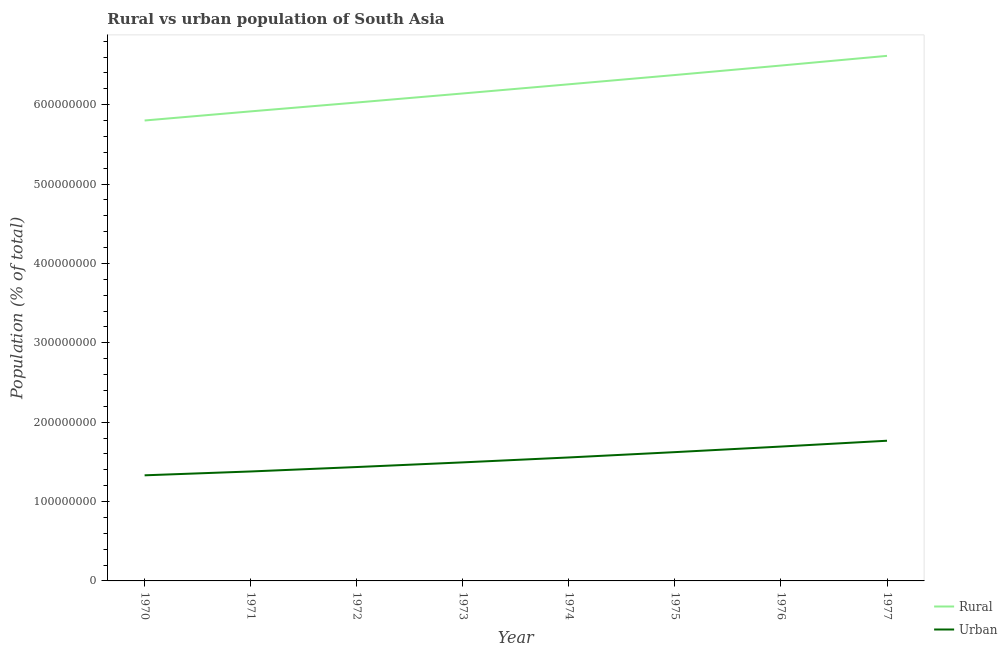Does the line corresponding to rural population density intersect with the line corresponding to urban population density?
Offer a terse response. No. Is the number of lines equal to the number of legend labels?
Provide a succinct answer. Yes. What is the rural population density in 1970?
Ensure brevity in your answer.  5.80e+08. Across all years, what is the maximum urban population density?
Make the answer very short. 1.77e+08. Across all years, what is the minimum urban population density?
Provide a succinct answer. 1.33e+08. In which year was the rural population density minimum?
Make the answer very short. 1970. What is the total urban population density in the graph?
Your answer should be compact. 1.23e+09. What is the difference between the urban population density in 1972 and that in 1974?
Provide a succinct answer. -1.21e+07. What is the difference between the urban population density in 1971 and the rural population density in 1972?
Your answer should be very brief. -4.65e+08. What is the average rural population density per year?
Offer a terse response. 6.20e+08. In the year 1975, what is the difference between the rural population density and urban population density?
Offer a very short reply. 4.75e+08. In how many years, is the rural population density greater than 40000000 %?
Your answer should be compact. 8. What is the ratio of the urban population density in 1972 to that in 1974?
Your answer should be very brief. 0.92. Is the difference between the rural population density in 1971 and 1972 greater than the difference between the urban population density in 1971 and 1972?
Provide a succinct answer. No. What is the difference between the highest and the second highest urban population density?
Give a very brief answer. 7.35e+06. What is the difference between the highest and the lowest urban population density?
Provide a succinct answer. 4.36e+07. In how many years, is the rural population density greater than the average rural population density taken over all years?
Offer a terse response. 4. Is the sum of the urban population density in 1972 and 1973 greater than the maximum rural population density across all years?
Provide a succinct answer. No. Is the urban population density strictly greater than the rural population density over the years?
Ensure brevity in your answer.  No. How many lines are there?
Your answer should be compact. 2. What is the difference between two consecutive major ticks on the Y-axis?
Your response must be concise. 1.00e+08. Does the graph contain any zero values?
Your answer should be very brief. No. Does the graph contain grids?
Provide a short and direct response. No. Where does the legend appear in the graph?
Make the answer very short. Bottom right. What is the title of the graph?
Offer a terse response. Rural vs urban population of South Asia. Does "Start a business" appear as one of the legend labels in the graph?
Your answer should be very brief. No. What is the label or title of the Y-axis?
Give a very brief answer. Population (% of total). What is the Population (% of total) in Rural in 1970?
Ensure brevity in your answer.  5.80e+08. What is the Population (% of total) in Urban in 1970?
Ensure brevity in your answer.  1.33e+08. What is the Population (% of total) of Rural in 1971?
Provide a short and direct response. 5.92e+08. What is the Population (% of total) in Urban in 1971?
Give a very brief answer. 1.38e+08. What is the Population (% of total) of Rural in 1972?
Make the answer very short. 6.03e+08. What is the Population (% of total) in Urban in 1972?
Keep it short and to the point. 1.43e+08. What is the Population (% of total) in Rural in 1973?
Ensure brevity in your answer.  6.14e+08. What is the Population (% of total) of Urban in 1973?
Your answer should be compact. 1.49e+08. What is the Population (% of total) in Rural in 1974?
Provide a succinct answer. 6.26e+08. What is the Population (% of total) of Urban in 1974?
Keep it short and to the point. 1.56e+08. What is the Population (% of total) of Rural in 1975?
Your answer should be very brief. 6.37e+08. What is the Population (% of total) in Urban in 1975?
Provide a succinct answer. 1.62e+08. What is the Population (% of total) of Rural in 1976?
Your answer should be compact. 6.49e+08. What is the Population (% of total) of Urban in 1976?
Your answer should be very brief. 1.69e+08. What is the Population (% of total) in Rural in 1977?
Your answer should be compact. 6.62e+08. What is the Population (% of total) of Urban in 1977?
Make the answer very short. 1.77e+08. Across all years, what is the maximum Population (% of total) of Rural?
Ensure brevity in your answer.  6.62e+08. Across all years, what is the maximum Population (% of total) in Urban?
Offer a very short reply. 1.77e+08. Across all years, what is the minimum Population (% of total) of Rural?
Keep it short and to the point. 5.80e+08. Across all years, what is the minimum Population (% of total) in Urban?
Offer a terse response. 1.33e+08. What is the total Population (% of total) of Rural in the graph?
Offer a terse response. 4.96e+09. What is the total Population (% of total) in Urban in the graph?
Make the answer very short. 1.23e+09. What is the difference between the Population (% of total) in Rural in 1970 and that in 1971?
Make the answer very short. -1.15e+07. What is the difference between the Population (% of total) of Urban in 1970 and that in 1971?
Give a very brief answer. -4.86e+06. What is the difference between the Population (% of total) of Rural in 1970 and that in 1972?
Your answer should be compact. -2.27e+07. What is the difference between the Population (% of total) in Urban in 1970 and that in 1972?
Keep it short and to the point. -1.05e+07. What is the difference between the Population (% of total) in Rural in 1970 and that in 1973?
Your answer should be compact. -3.41e+07. What is the difference between the Population (% of total) of Urban in 1970 and that in 1973?
Offer a terse response. -1.63e+07. What is the difference between the Population (% of total) of Rural in 1970 and that in 1974?
Your answer should be compact. -4.56e+07. What is the difference between the Population (% of total) of Urban in 1970 and that in 1974?
Your answer should be compact. -2.25e+07. What is the difference between the Population (% of total) in Rural in 1970 and that in 1975?
Make the answer very short. -5.73e+07. What is the difference between the Population (% of total) in Urban in 1970 and that in 1975?
Provide a succinct answer. -2.92e+07. What is the difference between the Population (% of total) of Rural in 1970 and that in 1976?
Your answer should be very brief. -6.93e+07. What is the difference between the Population (% of total) in Urban in 1970 and that in 1976?
Give a very brief answer. -3.62e+07. What is the difference between the Population (% of total) in Rural in 1970 and that in 1977?
Your answer should be very brief. -8.15e+07. What is the difference between the Population (% of total) of Urban in 1970 and that in 1977?
Give a very brief answer. -4.36e+07. What is the difference between the Population (% of total) in Rural in 1971 and that in 1972?
Your answer should be compact. -1.12e+07. What is the difference between the Population (% of total) in Urban in 1971 and that in 1972?
Your answer should be very brief. -5.59e+06. What is the difference between the Population (% of total) of Rural in 1971 and that in 1973?
Provide a succinct answer. -2.26e+07. What is the difference between the Population (% of total) of Urban in 1971 and that in 1973?
Your answer should be compact. -1.14e+07. What is the difference between the Population (% of total) in Rural in 1971 and that in 1974?
Offer a terse response. -3.41e+07. What is the difference between the Population (% of total) of Urban in 1971 and that in 1974?
Ensure brevity in your answer.  -1.77e+07. What is the difference between the Population (% of total) in Rural in 1971 and that in 1975?
Your answer should be compact. -4.58e+07. What is the difference between the Population (% of total) of Urban in 1971 and that in 1975?
Your answer should be very brief. -2.44e+07. What is the difference between the Population (% of total) of Rural in 1971 and that in 1976?
Your response must be concise. -5.78e+07. What is the difference between the Population (% of total) in Urban in 1971 and that in 1976?
Offer a very short reply. -3.14e+07. What is the difference between the Population (% of total) in Rural in 1971 and that in 1977?
Make the answer very short. -7.00e+07. What is the difference between the Population (% of total) in Urban in 1971 and that in 1977?
Ensure brevity in your answer.  -3.87e+07. What is the difference between the Population (% of total) of Rural in 1972 and that in 1973?
Ensure brevity in your answer.  -1.14e+07. What is the difference between the Population (% of total) in Urban in 1972 and that in 1973?
Offer a very short reply. -5.85e+06. What is the difference between the Population (% of total) of Rural in 1972 and that in 1974?
Your answer should be compact. -2.30e+07. What is the difference between the Population (% of total) in Urban in 1972 and that in 1974?
Give a very brief answer. -1.21e+07. What is the difference between the Population (% of total) of Rural in 1972 and that in 1975?
Your answer should be very brief. -3.46e+07. What is the difference between the Population (% of total) in Urban in 1972 and that in 1975?
Keep it short and to the point. -1.88e+07. What is the difference between the Population (% of total) of Rural in 1972 and that in 1976?
Your response must be concise. -4.66e+07. What is the difference between the Population (% of total) of Urban in 1972 and that in 1976?
Ensure brevity in your answer.  -2.58e+07. What is the difference between the Population (% of total) in Rural in 1972 and that in 1977?
Your answer should be very brief. -5.88e+07. What is the difference between the Population (% of total) of Urban in 1972 and that in 1977?
Give a very brief answer. -3.31e+07. What is the difference between the Population (% of total) of Rural in 1973 and that in 1974?
Your answer should be very brief. -1.15e+07. What is the difference between the Population (% of total) of Urban in 1973 and that in 1974?
Your response must be concise. -6.21e+06. What is the difference between the Population (% of total) in Rural in 1973 and that in 1975?
Offer a terse response. -2.32e+07. What is the difference between the Population (% of total) of Urban in 1973 and that in 1975?
Offer a terse response. -1.29e+07. What is the difference between the Population (% of total) in Rural in 1973 and that in 1976?
Your answer should be compact. -3.52e+07. What is the difference between the Population (% of total) in Urban in 1973 and that in 1976?
Your answer should be very brief. -1.99e+07. What is the difference between the Population (% of total) of Rural in 1973 and that in 1977?
Your answer should be compact. -4.74e+07. What is the difference between the Population (% of total) in Urban in 1973 and that in 1977?
Ensure brevity in your answer.  -2.73e+07. What is the difference between the Population (% of total) of Rural in 1974 and that in 1975?
Your response must be concise. -1.17e+07. What is the difference between the Population (% of total) in Urban in 1974 and that in 1975?
Your answer should be compact. -6.69e+06. What is the difference between the Population (% of total) of Rural in 1974 and that in 1976?
Offer a terse response. -2.36e+07. What is the difference between the Population (% of total) of Urban in 1974 and that in 1976?
Provide a succinct answer. -1.37e+07. What is the difference between the Population (% of total) in Rural in 1974 and that in 1977?
Your answer should be very brief. -3.58e+07. What is the difference between the Population (% of total) in Urban in 1974 and that in 1977?
Offer a terse response. -2.11e+07. What is the difference between the Population (% of total) of Rural in 1975 and that in 1976?
Your response must be concise. -1.20e+07. What is the difference between the Population (% of total) of Urban in 1975 and that in 1976?
Ensure brevity in your answer.  -7.01e+06. What is the difference between the Population (% of total) of Rural in 1975 and that in 1977?
Your answer should be very brief. -2.42e+07. What is the difference between the Population (% of total) of Urban in 1975 and that in 1977?
Keep it short and to the point. -1.44e+07. What is the difference between the Population (% of total) in Rural in 1976 and that in 1977?
Keep it short and to the point. -1.22e+07. What is the difference between the Population (% of total) of Urban in 1976 and that in 1977?
Offer a terse response. -7.35e+06. What is the difference between the Population (% of total) of Rural in 1970 and the Population (% of total) of Urban in 1971?
Provide a succinct answer. 4.42e+08. What is the difference between the Population (% of total) of Rural in 1970 and the Population (% of total) of Urban in 1972?
Give a very brief answer. 4.37e+08. What is the difference between the Population (% of total) of Rural in 1970 and the Population (% of total) of Urban in 1973?
Provide a succinct answer. 4.31e+08. What is the difference between the Population (% of total) of Rural in 1970 and the Population (% of total) of Urban in 1974?
Give a very brief answer. 4.25e+08. What is the difference between the Population (% of total) of Rural in 1970 and the Population (% of total) of Urban in 1975?
Keep it short and to the point. 4.18e+08. What is the difference between the Population (% of total) of Rural in 1970 and the Population (% of total) of Urban in 1976?
Your answer should be very brief. 4.11e+08. What is the difference between the Population (% of total) in Rural in 1970 and the Population (% of total) in Urban in 1977?
Keep it short and to the point. 4.03e+08. What is the difference between the Population (% of total) of Rural in 1971 and the Population (% of total) of Urban in 1972?
Your answer should be compact. 4.48e+08. What is the difference between the Population (% of total) of Rural in 1971 and the Population (% of total) of Urban in 1973?
Make the answer very short. 4.42e+08. What is the difference between the Population (% of total) of Rural in 1971 and the Population (% of total) of Urban in 1974?
Make the answer very short. 4.36e+08. What is the difference between the Population (% of total) in Rural in 1971 and the Population (% of total) in Urban in 1975?
Provide a succinct answer. 4.29e+08. What is the difference between the Population (% of total) in Rural in 1971 and the Population (% of total) in Urban in 1976?
Offer a very short reply. 4.22e+08. What is the difference between the Population (% of total) in Rural in 1971 and the Population (% of total) in Urban in 1977?
Ensure brevity in your answer.  4.15e+08. What is the difference between the Population (% of total) in Rural in 1972 and the Population (% of total) in Urban in 1973?
Provide a short and direct response. 4.53e+08. What is the difference between the Population (% of total) in Rural in 1972 and the Population (% of total) in Urban in 1974?
Keep it short and to the point. 4.47e+08. What is the difference between the Population (% of total) in Rural in 1972 and the Population (% of total) in Urban in 1975?
Your answer should be very brief. 4.40e+08. What is the difference between the Population (% of total) of Rural in 1972 and the Population (% of total) of Urban in 1976?
Offer a very short reply. 4.33e+08. What is the difference between the Population (% of total) in Rural in 1972 and the Population (% of total) in Urban in 1977?
Offer a terse response. 4.26e+08. What is the difference between the Population (% of total) in Rural in 1973 and the Population (% of total) in Urban in 1974?
Your answer should be compact. 4.59e+08. What is the difference between the Population (% of total) in Rural in 1973 and the Population (% of total) in Urban in 1975?
Your response must be concise. 4.52e+08. What is the difference between the Population (% of total) of Rural in 1973 and the Population (% of total) of Urban in 1976?
Keep it short and to the point. 4.45e+08. What is the difference between the Population (% of total) of Rural in 1973 and the Population (% of total) of Urban in 1977?
Keep it short and to the point. 4.38e+08. What is the difference between the Population (% of total) of Rural in 1974 and the Population (% of total) of Urban in 1975?
Make the answer very short. 4.63e+08. What is the difference between the Population (% of total) in Rural in 1974 and the Population (% of total) in Urban in 1976?
Provide a succinct answer. 4.56e+08. What is the difference between the Population (% of total) in Rural in 1974 and the Population (% of total) in Urban in 1977?
Your answer should be compact. 4.49e+08. What is the difference between the Population (% of total) of Rural in 1975 and the Population (% of total) of Urban in 1976?
Your answer should be compact. 4.68e+08. What is the difference between the Population (% of total) in Rural in 1975 and the Population (% of total) in Urban in 1977?
Keep it short and to the point. 4.61e+08. What is the difference between the Population (% of total) of Rural in 1976 and the Population (% of total) of Urban in 1977?
Your answer should be very brief. 4.73e+08. What is the average Population (% of total) of Rural per year?
Your answer should be compact. 6.20e+08. What is the average Population (% of total) of Urban per year?
Ensure brevity in your answer.  1.53e+08. In the year 1970, what is the difference between the Population (% of total) in Rural and Population (% of total) in Urban?
Ensure brevity in your answer.  4.47e+08. In the year 1971, what is the difference between the Population (% of total) in Rural and Population (% of total) in Urban?
Your response must be concise. 4.54e+08. In the year 1972, what is the difference between the Population (% of total) in Rural and Population (% of total) in Urban?
Your answer should be very brief. 4.59e+08. In the year 1973, what is the difference between the Population (% of total) of Rural and Population (% of total) of Urban?
Your answer should be compact. 4.65e+08. In the year 1974, what is the difference between the Population (% of total) in Rural and Population (% of total) in Urban?
Provide a succinct answer. 4.70e+08. In the year 1975, what is the difference between the Population (% of total) of Rural and Population (% of total) of Urban?
Ensure brevity in your answer.  4.75e+08. In the year 1976, what is the difference between the Population (% of total) in Rural and Population (% of total) in Urban?
Provide a short and direct response. 4.80e+08. In the year 1977, what is the difference between the Population (% of total) in Rural and Population (% of total) in Urban?
Keep it short and to the point. 4.85e+08. What is the ratio of the Population (% of total) of Rural in 1970 to that in 1971?
Offer a very short reply. 0.98. What is the ratio of the Population (% of total) of Urban in 1970 to that in 1971?
Keep it short and to the point. 0.96. What is the ratio of the Population (% of total) of Rural in 1970 to that in 1972?
Give a very brief answer. 0.96. What is the ratio of the Population (% of total) in Urban in 1970 to that in 1972?
Keep it short and to the point. 0.93. What is the ratio of the Population (% of total) of Rural in 1970 to that in 1973?
Make the answer very short. 0.94. What is the ratio of the Population (% of total) in Urban in 1970 to that in 1973?
Ensure brevity in your answer.  0.89. What is the ratio of the Population (% of total) in Rural in 1970 to that in 1974?
Offer a very short reply. 0.93. What is the ratio of the Population (% of total) of Urban in 1970 to that in 1974?
Offer a terse response. 0.86. What is the ratio of the Population (% of total) of Rural in 1970 to that in 1975?
Offer a terse response. 0.91. What is the ratio of the Population (% of total) in Urban in 1970 to that in 1975?
Your answer should be very brief. 0.82. What is the ratio of the Population (% of total) of Rural in 1970 to that in 1976?
Your answer should be very brief. 0.89. What is the ratio of the Population (% of total) in Urban in 1970 to that in 1976?
Provide a short and direct response. 0.79. What is the ratio of the Population (% of total) in Rural in 1970 to that in 1977?
Offer a very short reply. 0.88. What is the ratio of the Population (% of total) in Urban in 1970 to that in 1977?
Make the answer very short. 0.75. What is the ratio of the Population (% of total) in Rural in 1971 to that in 1972?
Your answer should be very brief. 0.98. What is the ratio of the Population (% of total) in Urban in 1971 to that in 1972?
Provide a short and direct response. 0.96. What is the ratio of the Population (% of total) of Rural in 1971 to that in 1973?
Offer a very short reply. 0.96. What is the ratio of the Population (% of total) in Urban in 1971 to that in 1973?
Ensure brevity in your answer.  0.92. What is the ratio of the Population (% of total) in Rural in 1971 to that in 1974?
Give a very brief answer. 0.95. What is the ratio of the Population (% of total) in Urban in 1971 to that in 1974?
Offer a terse response. 0.89. What is the ratio of the Population (% of total) in Rural in 1971 to that in 1975?
Ensure brevity in your answer.  0.93. What is the ratio of the Population (% of total) of Urban in 1971 to that in 1975?
Offer a terse response. 0.85. What is the ratio of the Population (% of total) of Rural in 1971 to that in 1976?
Provide a succinct answer. 0.91. What is the ratio of the Population (% of total) of Urban in 1971 to that in 1976?
Offer a terse response. 0.81. What is the ratio of the Population (% of total) of Rural in 1971 to that in 1977?
Your answer should be very brief. 0.89. What is the ratio of the Population (% of total) in Urban in 1971 to that in 1977?
Your answer should be compact. 0.78. What is the ratio of the Population (% of total) in Rural in 1972 to that in 1973?
Provide a short and direct response. 0.98. What is the ratio of the Population (% of total) of Urban in 1972 to that in 1973?
Offer a terse response. 0.96. What is the ratio of the Population (% of total) of Rural in 1972 to that in 1974?
Make the answer very short. 0.96. What is the ratio of the Population (% of total) of Urban in 1972 to that in 1974?
Offer a very short reply. 0.92. What is the ratio of the Population (% of total) in Rural in 1972 to that in 1975?
Your answer should be very brief. 0.95. What is the ratio of the Population (% of total) of Urban in 1972 to that in 1975?
Make the answer very short. 0.88. What is the ratio of the Population (% of total) of Rural in 1972 to that in 1976?
Keep it short and to the point. 0.93. What is the ratio of the Population (% of total) in Urban in 1972 to that in 1976?
Provide a short and direct response. 0.85. What is the ratio of the Population (% of total) in Rural in 1972 to that in 1977?
Offer a terse response. 0.91. What is the ratio of the Population (% of total) in Urban in 1972 to that in 1977?
Your answer should be very brief. 0.81. What is the ratio of the Population (% of total) in Rural in 1973 to that in 1974?
Keep it short and to the point. 0.98. What is the ratio of the Population (% of total) of Urban in 1973 to that in 1974?
Give a very brief answer. 0.96. What is the ratio of the Population (% of total) in Rural in 1973 to that in 1975?
Your answer should be very brief. 0.96. What is the ratio of the Population (% of total) in Urban in 1973 to that in 1975?
Your answer should be very brief. 0.92. What is the ratio of the Population (% of total) in Rural in 1973 to that in 1976?
Provide a short and direct response. 0.95. What is the ratio of the Population (% of total) in Urban in 1973 to that in 1976?
Ensure brevity in your answer.  0.88. What is the ratio of the Population (% of total) in Rural in 1973 to that in 1977?
Offer a terse response. 0.93. What is the ratio of the Population (% of total) in Urban in 1973 to that in 1977?
Offer a terse response. 0.85. What is the ratio of the Population (% of total) of Rural in 1974 to that in 1975?
Make the answer very short. 0.98. What is the ratio of the Population (% of total) of Urban in 1974 to that in 1975?
Keep it short and to the point. 0.96. What is the ratio of the Population (% of total) of Rural in 1974 to that in 1976?
Offer a very short reply. 0.96. What is the ratio of the Population (% of total) of Urban in 1974 to that in 1976?
Your response must be concise. 0.92. What is the ratio of the Population (% of total) of Rural in 1974 to that in 1977?
Make the answer very short. 0.95. What is the ratio of the Population (% of total) in Urban in 1974 to that in 1977?
Your answer should be very brief. 0.88. What is the ratio of the Population (% of total) in Rural in 1975 to that in 1976?
Offer a terse response. 0.98. What is the ratio of the Population (% of total) in Urban in 1975 to that in 1976?
Provide a short and direct response. 0.96. What is the ratio of the Population (% of total) of Rural in 1975 to that in 1977?
Your answer should be very brief. 0.96. What is the ratio of the Population (% of total) in Urban in 1975 to that in 1977?
Your response must be concise. 0.92. What is the ratio of the Population (% of total) of Rural in 1976 to that in 1977?
Ensure brevity in your answer.  0.98. What is the ratio of the Population (% of total) of Urban in 1976 to that in 1977?
Make the answer very short. 0.96. What is the difference between the highest and the second highest Population (% of total) in Rural?
Provide a succinct answer. 1.22e+07. What is the difference between the highest and the second highest Population (% of total) in Urban?
Your response must be concise. 7.35e+06. What is the difference between the highest and the lowest Population (% of total) in Rural?
Keep it short and to the point. 8.15e+07. What is the difference between the highest and the lowest Population (% of total) of Urban?
Your response must be concise. 4.36e+07. 